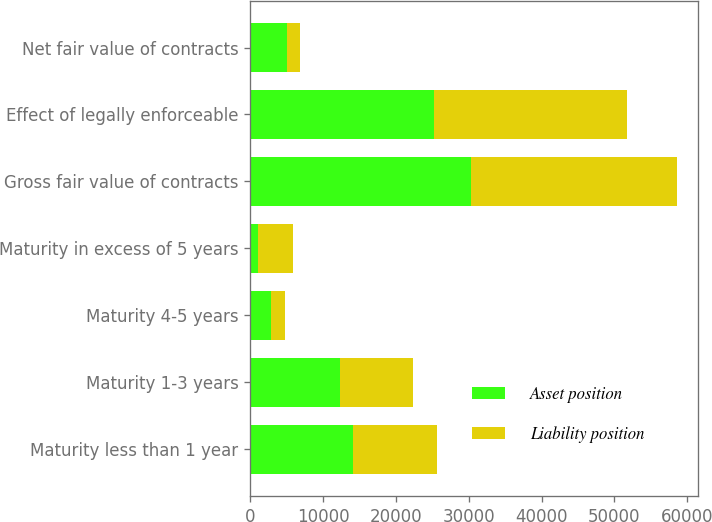Convert chart to OTSL. <chart><loc_0><loc_0><loc_500><loc_500><stacked_bar_chart><ecel><fcel>Maturity less than 1 year<fcel>Maturity 1-3 years<fcel>Maturity 4-5 years<fcel>Maturity in excess of 5 years<fcel>Gross fair value of contracts<fcel>Effect of legally enforceable<fcel>Net fair value of contracts<nl><fcel>Asset position<fcel>14130<fcel>12352<fcel>2787<fcel>1040<fcel>30309<fcel>25282<fcel>5027<nl><fcel>Liability position<fcel>11544<fcel>9962<fcel>1960<fcel>4761<fcel>28227<fcel>26490<fcel>1737<nl></chart> 